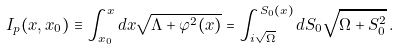Convert formula to latex. <formula><loc_0><loc_0><loc_500><loc_500>I _ { p } ( x , x _ { 0 } ) \equiv \int ^ { x } _ { x _ { 0 } } { d x \sqrt { \Lambda + \varphi ^ { 2 } ( x ) } } = \int ^ { S _ { 0 } ( x ) } _ { i \sqrt { \Omega } } { d S _ { 0 } \sqrt { \Omega + S _ { 0 } ^ { 2 } } } \, .</formula> 